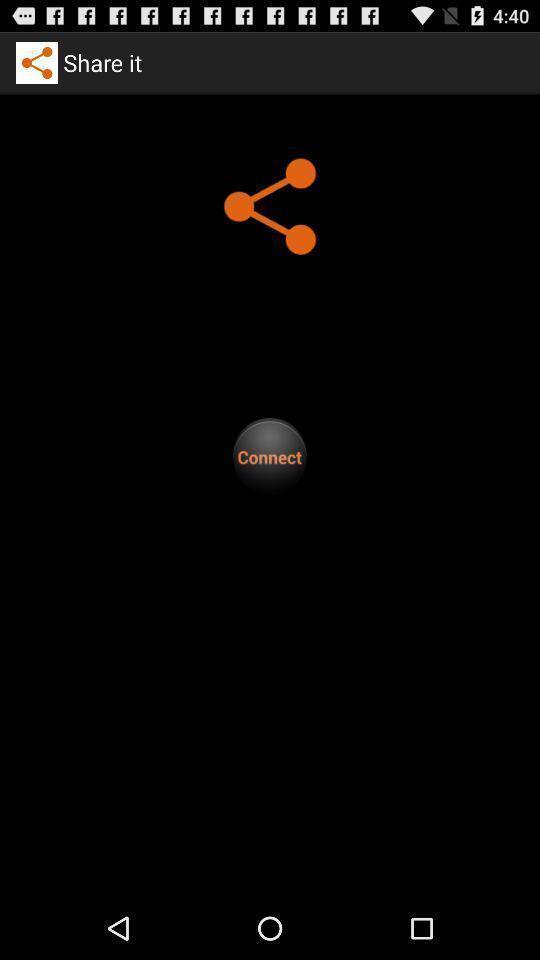Summarize the information in this screenshot. Screen shows connect option in a sharing app. 